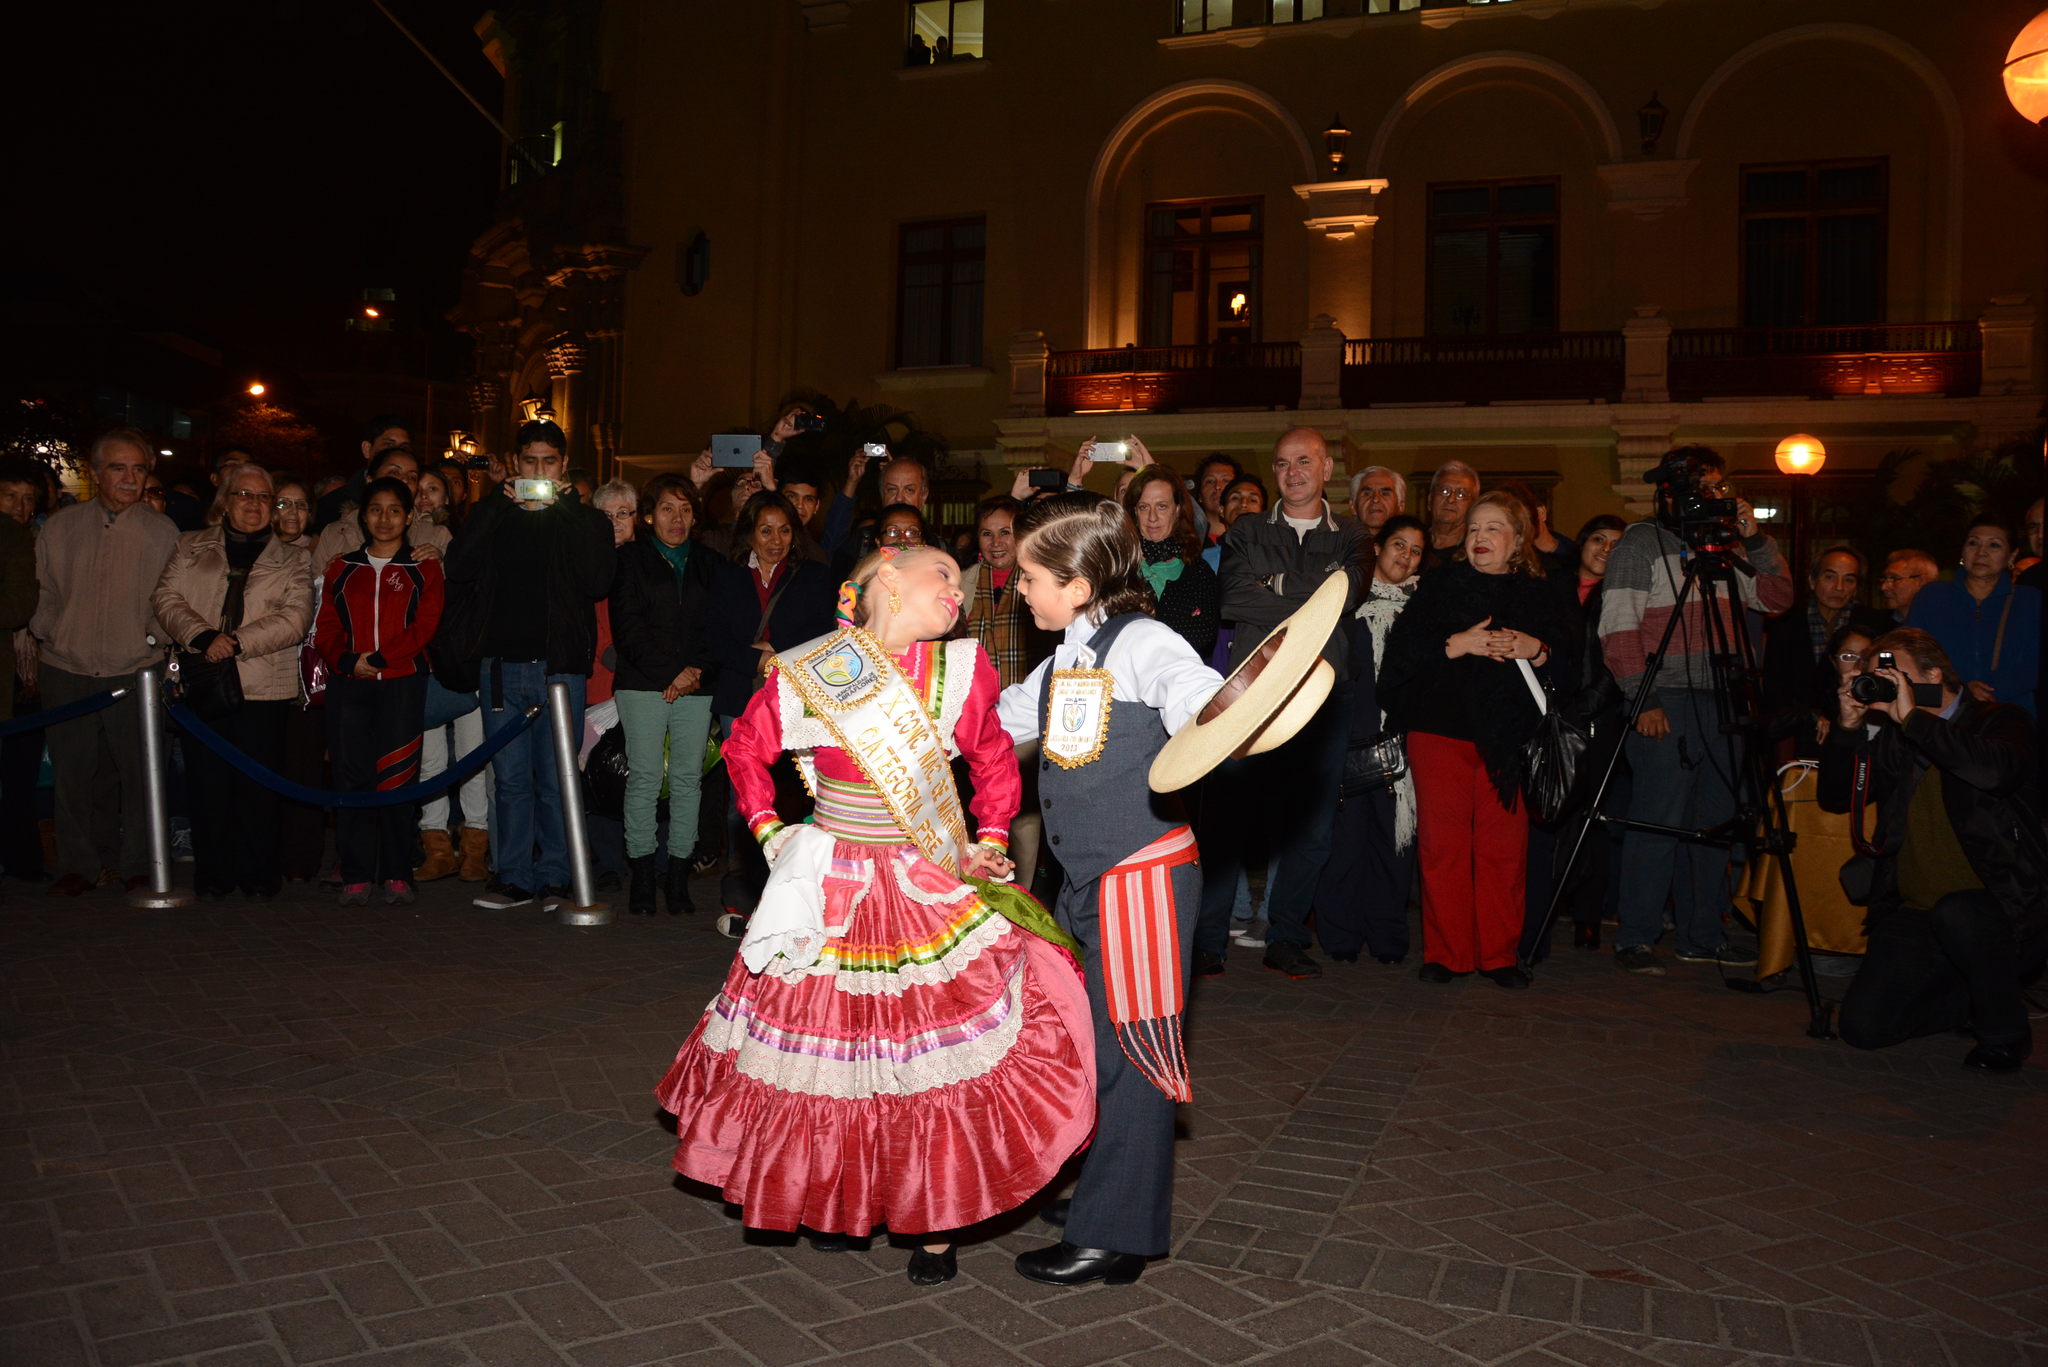Could you give a brief overview of what you see in this image? In this image I can see two persons standing. The person at right wearing gray and white color dress and holding a cap, the person at left wearing white and red color dress. Background I can see few other persons standing and the person at left holding a camera. I can also see few building. 